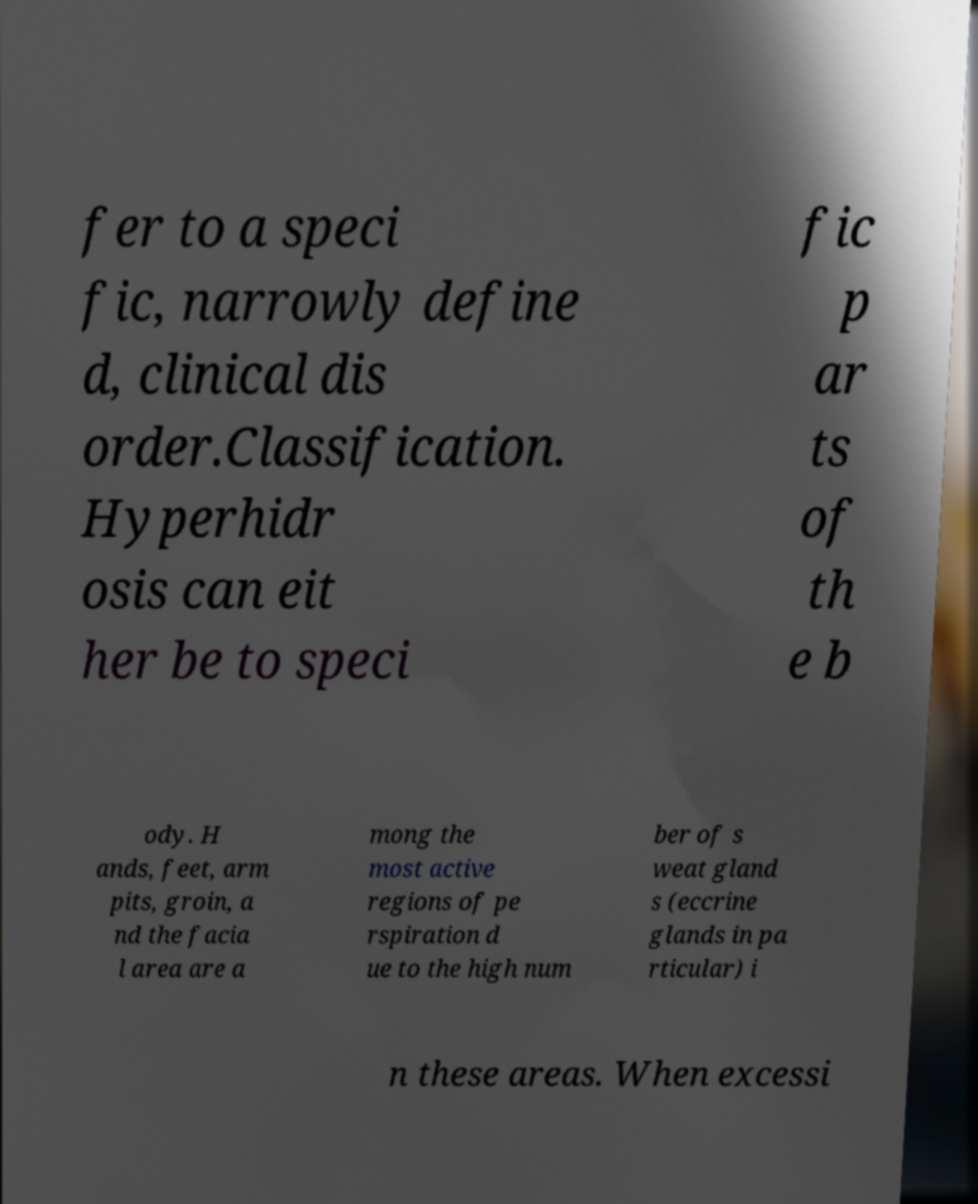Can you accurately transcribe the text from the provided image for me? fer to a speci fic, narrowly define d, clinical dis order.Classification. Hyperhidr osis can eit her be to speci fic p ar ts of th e b ody. H ands, feet, arm pits, groin, a nd the facia l area are a mong the most active regions of pe rspiration d ue to the high num ber of s weat gland s (eccrine glands in pa rticular) i n these areas. When excessi 